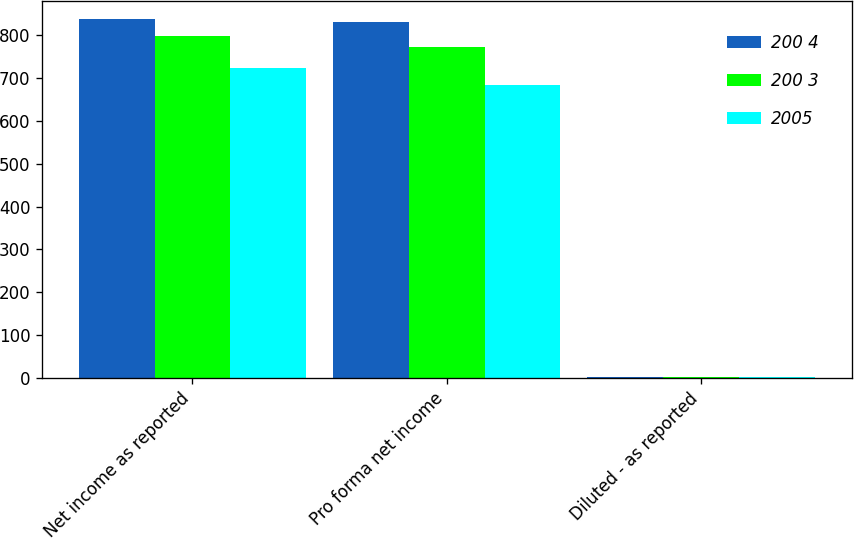<chart> <loc_0><loc_0><loc_500><loc_500><stacked_bar_chart><ecel><fcel>Net income as reported<fcel>Pro forma net income<fcel>Diluted - as reported<nl><fcel>200 4<fcel>838<fcel>831<fcel>2.5<nl><fcel>200 3<fcel>798<fcel>771<fcel>2.35<nl><fcel>2005<fcel>722<fcel>683<fcel>2.15<nl></chart> 